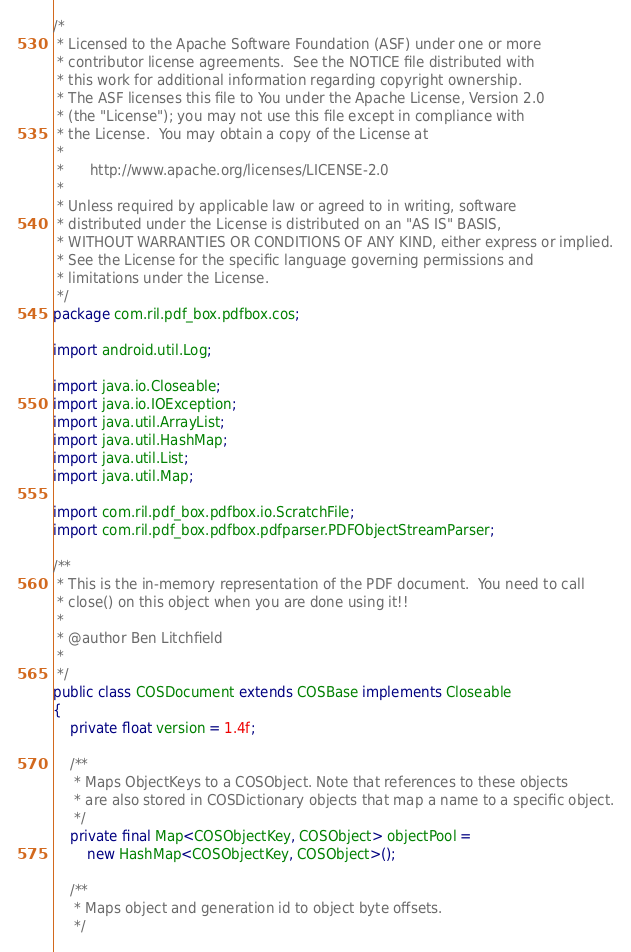Convert code to text. <code><loc_0><loc_0><loc_500><loc_500><_Java_>/*
 * Licensed to the Apache Software Foundation (ASF) under one or more
 * contributor license agreements.  See the NOTICE file distributed with
 * this work for additional information regarding copyright ownership.
 * The ASF licenses this file to You under the Apache License, Version 2.0
 * (the "License"); you may not use this file except in compliance with
 * the License.  You may obtain a copy of the License at
 *
 *      http://www.apache.org/licenses/LICENSE-2.0
 *
 * Unless required by applicable law or agreed to in writing, software
 * distributed under the License is distributed on an "AS IS" BASIS,
 * WITHOUT WARRANTIES OR CONDITIONS OF ANY KIND, either express or implied.
 * See the License for the specific language governing permissions and
 * limitations under the License.
 */
package com.ril.pdf_box.pdfbox.cos;

import android.util.Log;

import java.io.Closeable;
import java.io.IOException;
import java.util.ArrayList;
import java.util.HashMap;
import java.util.List;
import java.util.Map;

import com.ril.pdf_box.pdfbox.io.ScratchFile;
import com.ril.pdf_box.pdfbox.pdfparser.PDFObjectStreamParser;

/**
 * This is the in-memory representation of the PDF document.  You need to call
 * close() on this object when you are done using it!!
 *
 * @author Ben Litchfield
 *
 */
public class COSDocument extends COSBase implements Closeable
{
    private float version = 1.4f;

    /**
     * Maps ObjectKeys to a COSObject. Note that references to these objects
     * are also stored in COSDictionary objects that map a name to a specific object.
     */
    private final Map<COSObjectKey, COSObject> objectPool =
        new HashMap<COSObjectKey, COSObject>();

    /**
     * Maps object and generation id to object byte offsets.
     */</code> 